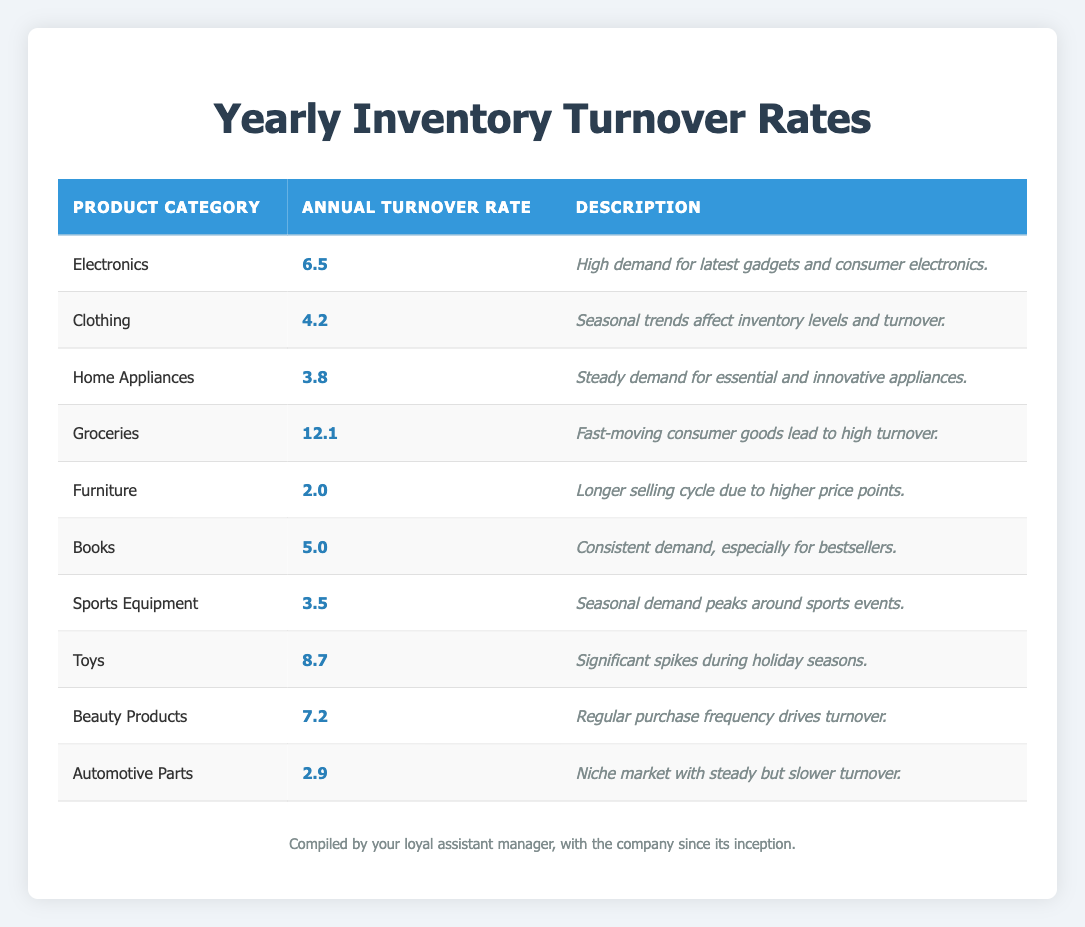What is the annual turnover rate for Electronics? The turnover rate for Electronics is specified in the table under the "Annual Turnover Rate" column next to the "Electronics" row, which shows a value of 6.5.
Answer: 6.5 Which product category has the highest annual turnover rate? By comparing the annual turnover rates for all product categories in the table, Groceries has the highest rate at 12.1.
Answer: Groceries Is the annual turnover rate for Furniture higher than that for Automotive Parts? The turnover rate for Furniture is 2.0 while for Automotive Parts it is 2.9. Since 2.0 is not greater than 2.9, the statement is false.
Answer: No What is the average annual turnover rate across all product categories? To find the average, sum all the turnover rates (6.5 + 4.2 + 3.8 + 12.1 + 2.0 + 5.0 + 3.5 + 8.7 + 7.2 + 2.9 = 54.9) and then divide by the number of categories (10). The average is 54.9 / 10 = 5.49.
Answer: 5.49 How many product categories have an annual turnover rate above 5? By examining the table, the categories with rates above 5 are Electronics (6.5), Groceries (12.1), Toys (8.7), and Beauty Products (7.2). That totals to 4 categories.
Answer: 4 What is the difference in turnover rates between Clothing and Home Appliances? The turnover rate for Clothing is 4.2 and for Home Appliances, it is 3.8. The difference is 4.2 - 3.8 = 0.4.
Answer: 0.4 Are the turnover rates for Sports Equipment and Furniture equal? The turnover rate for Sports Equipment is 3.5 while for Furniture it is 2.0. Since these values are not the same, the answer is false.
Answer: No Which product category has a description indicating a longer selling cycle? Referring to the descriptions, Furniture is the only category mentioned with a longer selling cycle due to higher price points.
Answer: Furniture 